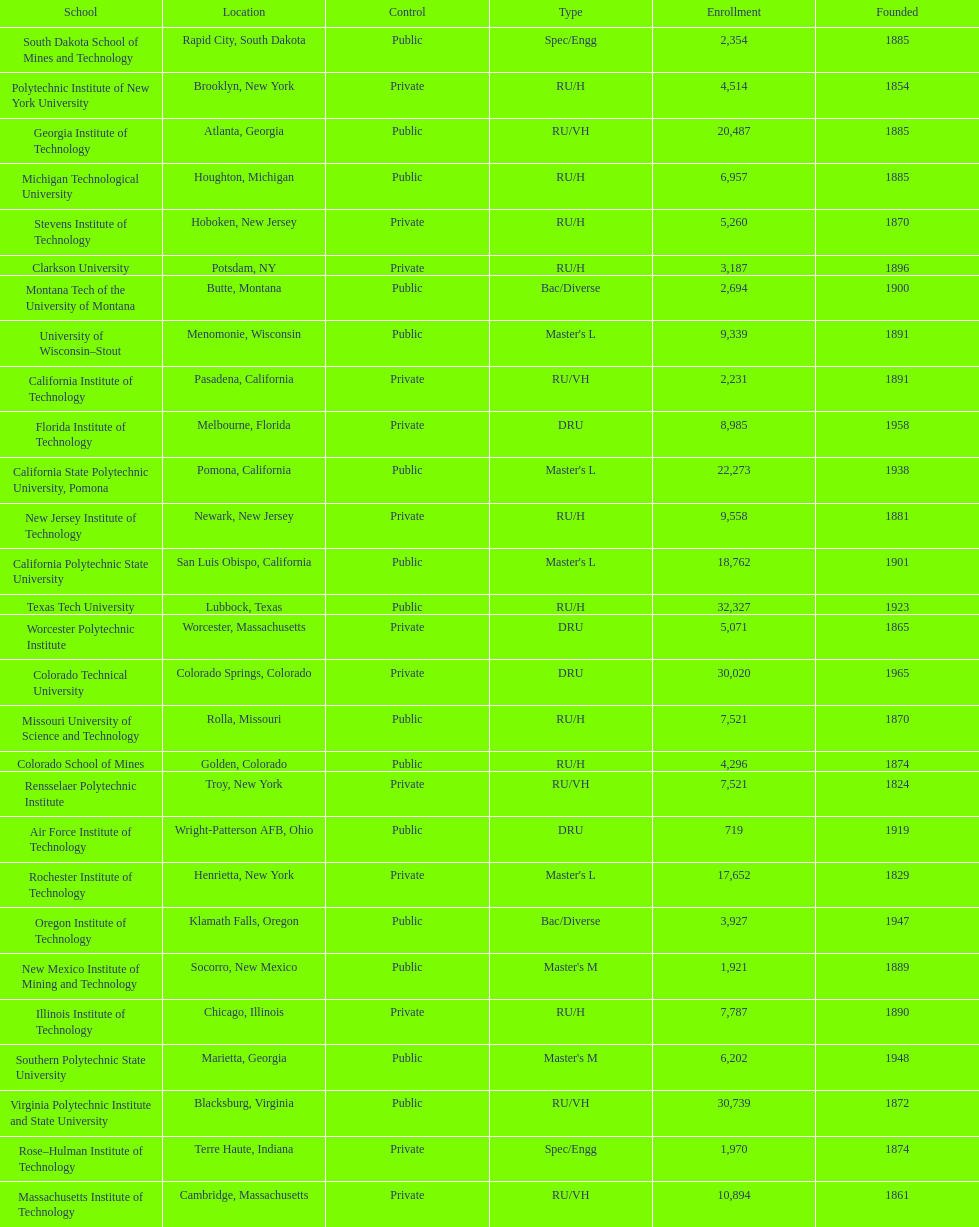How many of the universities were located in california? 3. 